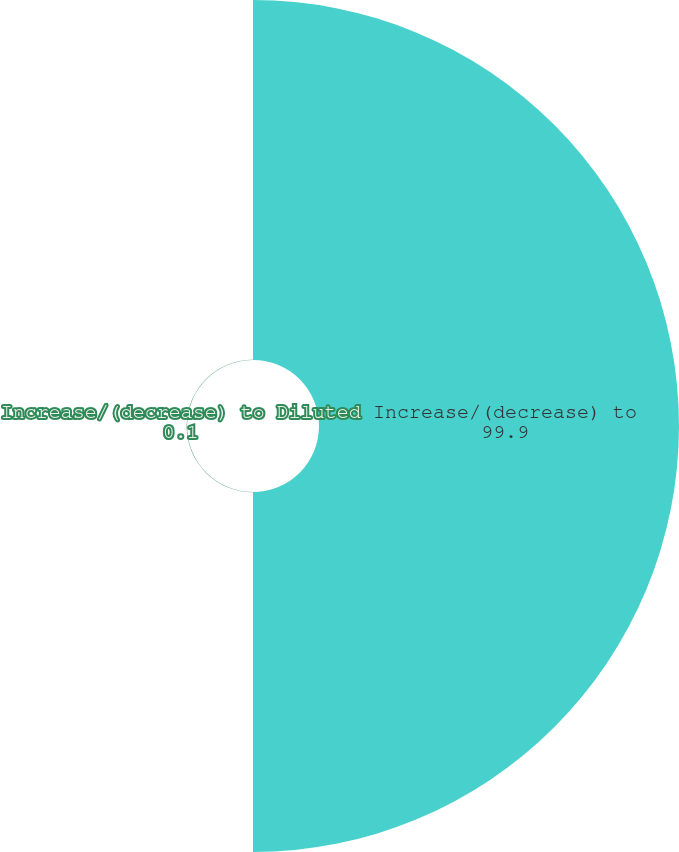Convert chart to OTSL. <chart><loc_0><loc_0><loc_500><loc_500><pie_chart><fcel>Increase/(decrease) to<fcel>Increase/(decrease) to Diluted<nl><fcel>99.9%<fcel>0.1%<nl></chart> 